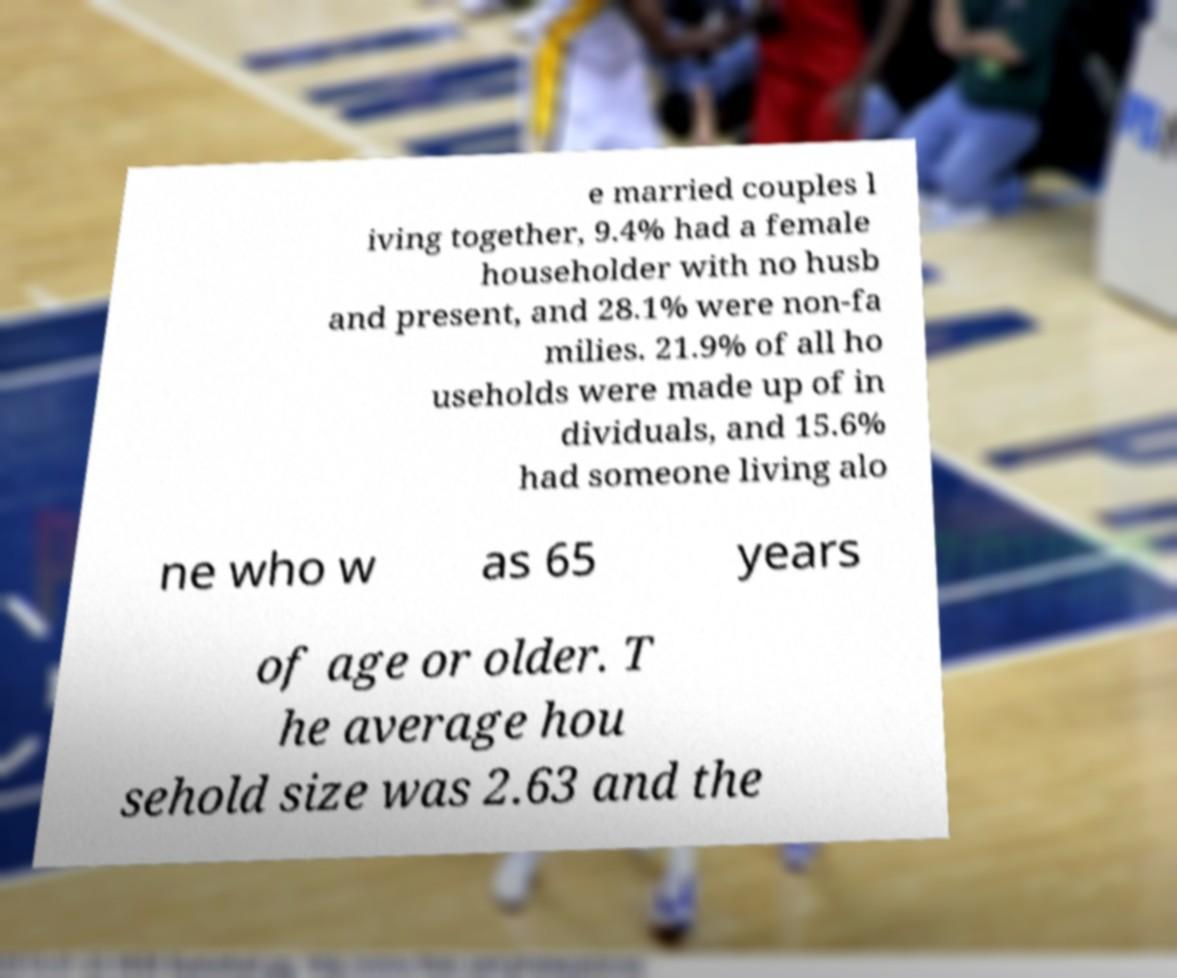What messages or text are displayed in this image? I need them in a readable, typed format. e married couples l iving together, 9.4% had a female householder with no husb and present, and 28.1% were non-fa milies. 21.9% of all ho useholds were made up of in dividuals, and 15.6% had someone living alo ne who w as 65 years of age or older. T he average hou sehold size was 2.63 and the 